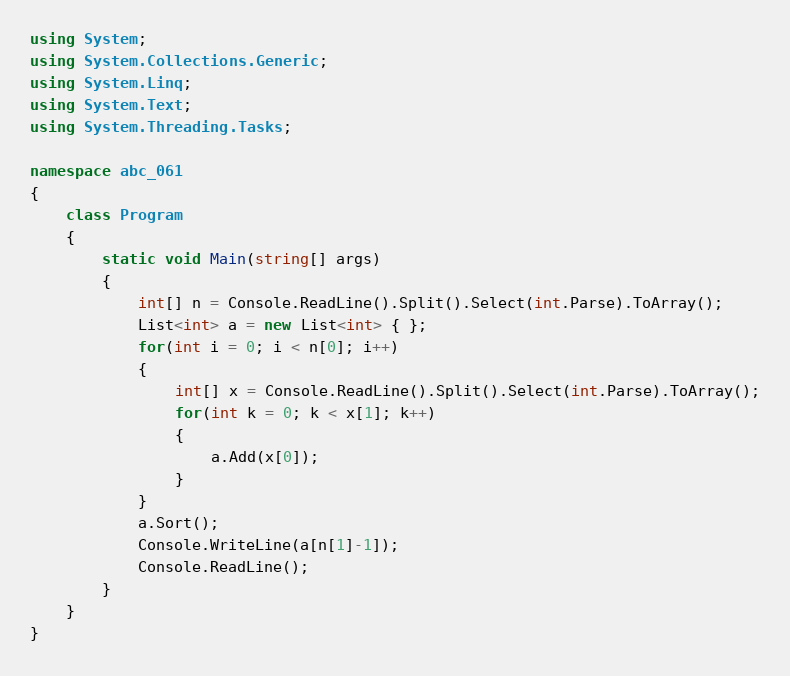<code> <loc_0><loc_0><loc_500><loc_500><_C#_>
using System;
using System.Collections.Generic;
using System.Linq;
using System.Text;
using System.Threading.Tasks;

namespace abc_061
{
    class Program
    {
        static void Main(string[] args)
        {
            int[] n = Console.ReadLine().Split().Select(int.Parse).ToArray();
            List<int> a = new List<int> { };
            for(int i = 0; i < n[0]; i++)
            {
                int[] x = Console.ReadLine().Split().Select(int.Parse).ToArray();
                for(int k = 0; k < x[1]; k++)
                {
                    a.Add(x[0]);
                }
            }
            a.Sort();
            Console.WriteLine(a[n[1]-1]);
            Console.ReadLine();
        }
    }
}
</code> 